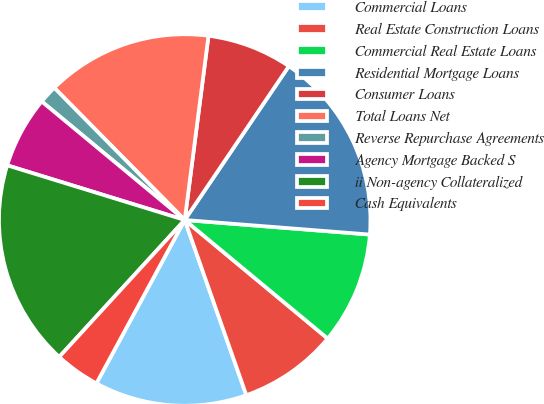Convert chart to OTSL. <chart><loc_0><loc_0><loc_500><loc_500><pie_chart><fcel>Commercial Loans<fcel>Real Estate Construction Loans<fcel>Commercial Real Estate Loans<fcel>Residential Mortgage Loans<fcel>Consumer Loans<fcel>Total Loans Net<fcel>Reverse Repurchase Agreements<fcel>Agency Mortgage Backed S<fcel>ii Non-agency Collateralized<fcel>Cash Equivalents<nl><fcel>13.27%<fcel>8.6%<fcel>9.77%<fcel>16.78%<fcel>7.43%<fcel>14.44%<fcel>1.59%<fcel>6.26%<fcel>17.95%<fcel>3.92%<nl></chart> 